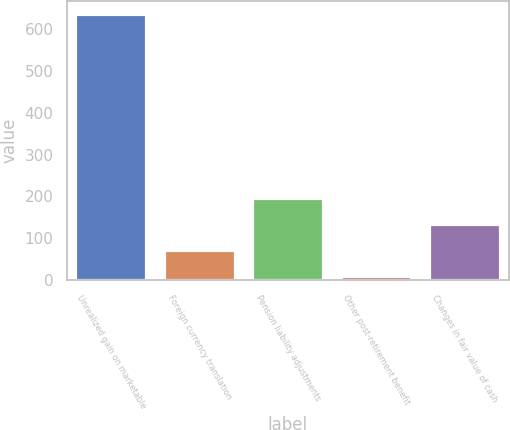<chart> <loc_0><loc_0><loc_500><loc_500><bar_chart><fcel>Unrealized gain on marketable<fcel>Foreign currency translation<fcel>Pension liability adjustments<fcel>Other post-retirement benefit<fcel>Changes in fair value of cash<nl><fcel>635<fcel>71.6<fcel>196.8<fcel>9<fcel>134.2<nl></chart> 